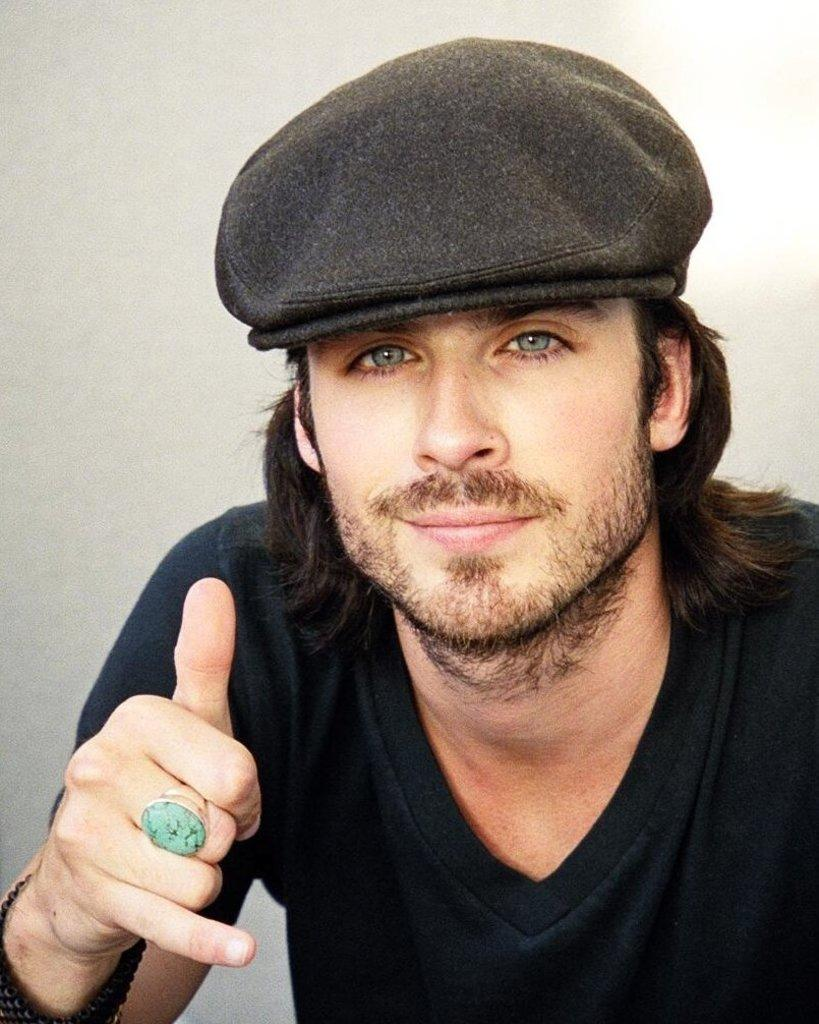What is the main subject of the image? There is a person in the image. What is the person wearing on their upper body? The person is wearing a black t-shirt. What is the person wearing on their head? The person is wearing a black hat. What color is the background of the image? The background of the image is white. How many ducks are visible in the image? There are no ducks present in the image. What type of horses can be seen in the image? There are no horses present in the image. 